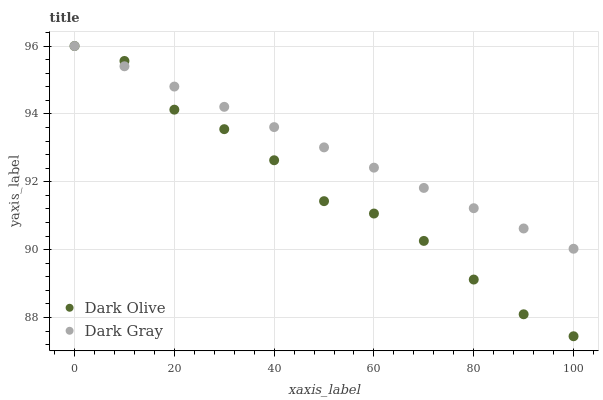Does Dark Olive have the minimum area under the curve?
Answer yes or no. Yes. Does Dark Gray have the maximum area under the curve?
Answer yes or no. Yes. Does Dark Olive have the maximum area under the curve?
Answer yes or no. No. Is Dark Gray the smoothest?
Answer yes or no. Yes. Is Dark Olive the roughest?
Answer yes or no. Yes. Is Dark Olive the smoothest?
Answer yes or no. No. Does Dark Olive have the lowest value?
Answer yes or no. Yes. Does Dark Olive have the highest value?
Answer yes or no. Yes. Does Dark Gray intersect Dark Olive?
Answer yes or no. Yes. Is Dark Gray less than Dark Olive?
Answer yes or no. No. Is Dark Gray greater than Dark Olive?
Answer yes or no. No. 